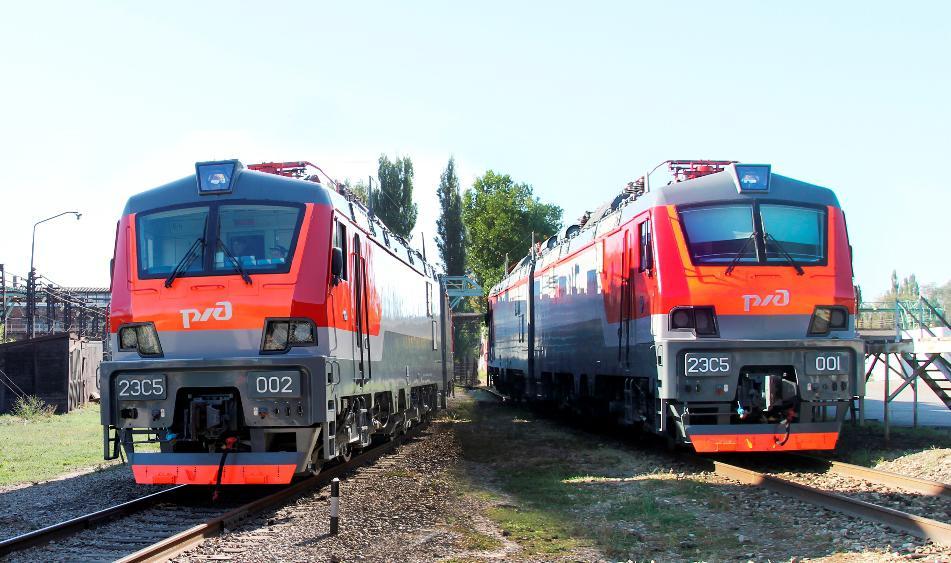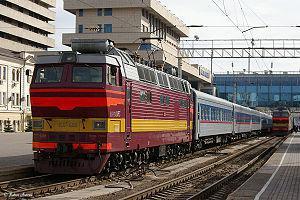The first image is the image on the left, the second image is the image on the right. For the images displayed, is the sentence "All trains are angled forward in the same direction." factually correct? Answer yes or no. No. 